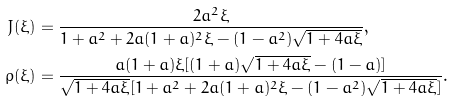Convert formula to latex. <formula><loc_0><loc_0><loc_500><loc_500>J ( \xi ) & = \frac { 2 a ^ { 2 } \xi } { 1 + a ^ { 2 } + 2 a ( 1 + a ) ^ { 2 } \xi - ( 1 - a ^ { 2 } ) \sqrt { 1 + 4 a \xi } } , \\ \rho ( \xi ) & = \frac { a ( 1 + a ) \xi [ ( 1 + a ) \sqrt { 1 + 4 a \xi } - ( 1 - a ) ] } { \sqrt { 1 + 4 a \xi } [ 1 + a ^ { 2 } + 2 a ( 1 + a ) ^ { 2 } \xi - ( 1 - a ^ { 2 } ) \sqrt { 1 + 4 a \xi } ] } .</formula> 